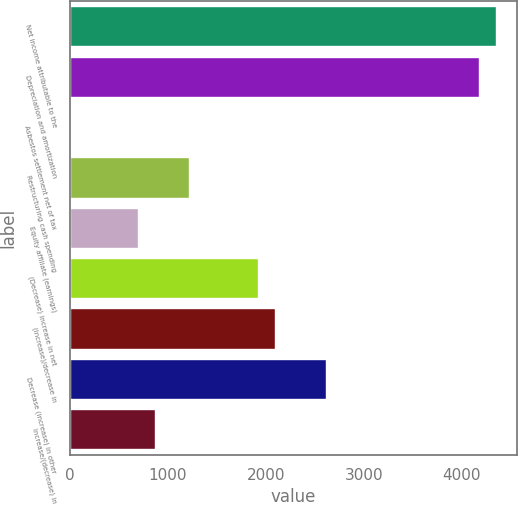<chart> <loc_0><loc_0><loc_500><loc_500><bar_chart><fcel>Net income attributable to the<fcel>Depreciation and amortization<fcel>Asbestos settlement net of tax<fcel>Restructuring cash spending<fcel>Equity affiliate (earnings)<fcel>(Decrease) increase in net<fcel>(Increase)/decrease in<fcel>Decrease (increase) in other<fcel>Increase/(decrease) in<nl><fcel>4347<fcel>4173.2<fcel>2<fcel>1218.6<fcel>697.2<fcel>1913.8<fcel>2087.6<fcel>2609<fcel>871<nl></chart> 